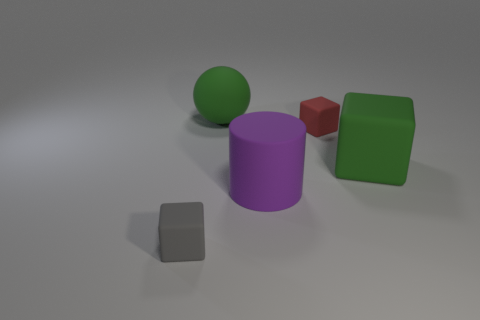There is a tiny red cube; are there any rubber blocks to the left of it?
Your answer should be very brief. Yes. How many other small objects have the same shape as the purple rubber object?
Make the answer very short. 0. Is the green ball made of the same material as the tiny block right of the tiny gray block?
Provide a succinct answer. Yes. How many rubber cylinders are there?
Provide a short and direct response. 1. What is the size of the object that is to the left of the big ball?
Provide a short and direct response. Small. What number of green objects are the same size as the gray matte thing?
Make the answer very short. 0. What material is the object that is both to the left of the purple cylinder and to the right of the tiny gray rubber cube?
Keep it short and to the point. Rubber. There is another object that is the same size as the gray object; what is its material?
Your answer should be compact. Rubber. What is the size of the green rubber object behind the small cube behind the small cube that is in front of the small red rubber thing?
Keep it short and to the point. Large. There is a gray object that is made of the same material as the large green ball; what is its size?
Make the answer very short. Small. 